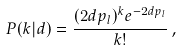<formula> <loc_0><loc_0><loc_500><loc_500>P ( k | d ) = \frac { ( 2 d p _ { l } ) ^ { k } e ^ { - 2 d p _ { l } } } { k ! } \, ,</formula> 